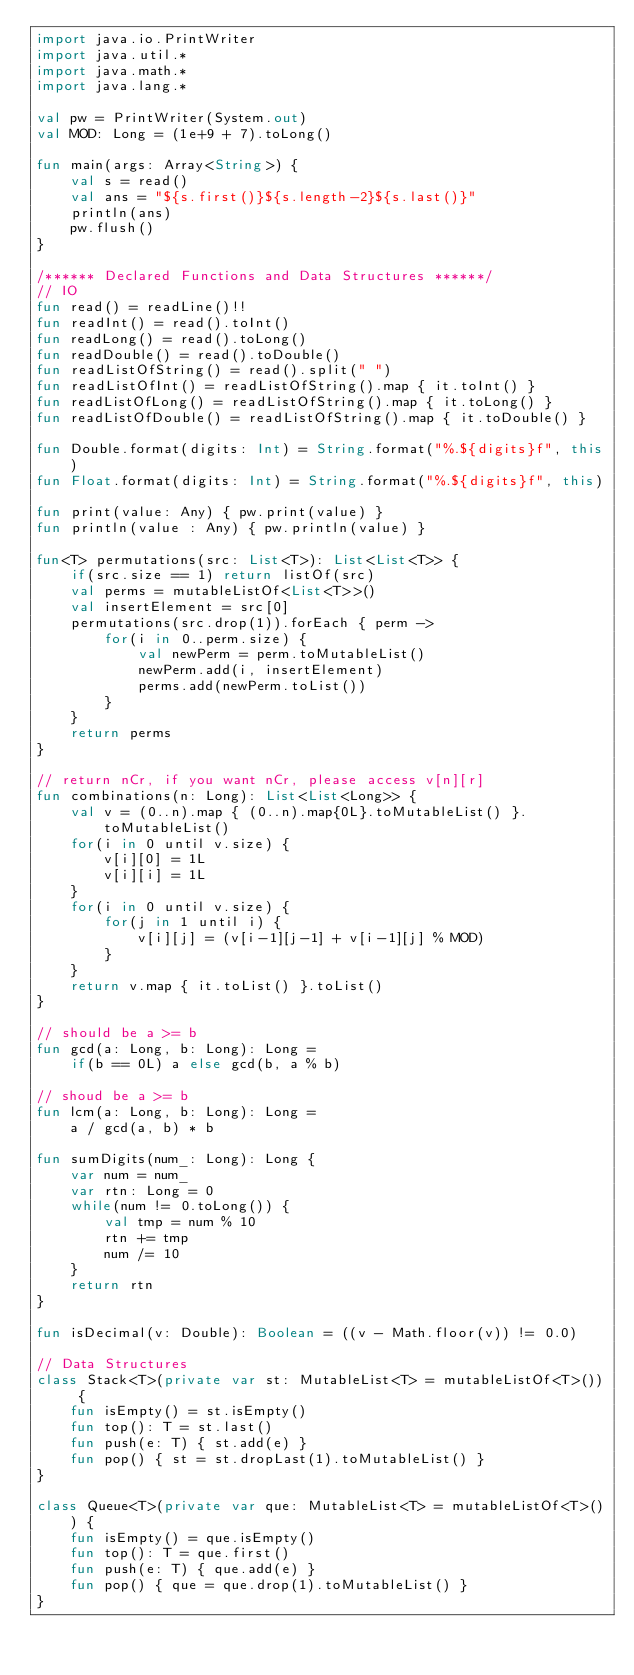<code> <loc_0><loc_0><loc_500><loc_500><_Kotlin_>import java.io.PrintWriter
import java.util.*
import java.math.*
import java.lang.*

val pw = PrintWriter(System.out)
val MOD: Long = (1e+9 + 7).toLong()

fun main(args: Array<String>) {
    val s = read() 
    val ans = "${s.first()}${s.length-2}${s.last()}"
    println(ans)
    pw.flush()
}

/****** Declared Functions and Data Structures ******/
// IO
fun read() = readLine()!!
fun readInt() = read().toInt()
fun readLong() = read().toLong()
fun readDouble() = read().toDouble()
fun readListOfString() = read().split(" ")
fun readListOfInt() = readListOfString().map { it.toInt() }
fun readListOfLong() = readListOfString().map { it.toLong() }
fun readListOfDouble() = readListOfString().map { it.toDouble() }

fun Double.format(digits: Int) = String.format("%.${digits}f", this)
fun Float.format(digits: Int) = String.format("%.${digits}f", this)

fun print(value: Any) { pw.print(value) }
fun println(value : Any) { pw.println(value) }

fun<T> permutations(src: List<T>): List<List<T>> {
    if(src.size == 1) return listOf(src)
    val perms = mutableListOf<List<T>>()
    val insertElement = src[0]
    permutations(src.drop(1)).forEach { perm ->
        for(i in 0..perm.size) {
            val newPerm = perm.toMutableList()
            newPerm.add(i, insertElement)
            perms.add(newPerm.toList())
        }
    }
    return perms
}

// return nCr, if you want nCr, please access v[n][r]
fun combinations(n: Long): List<List<Long>> {
    val v = (0..n).map { (0..n).map{0L}.toMutableList() }.toMutableList()
    for(i in 0 until v.size) {
        v[i][0] = 1L
        v[i][i] = 1L
    }
    for(i in 0 until v.size) {
        for(j in 1 until i) {
            v[i][j] = (v[i-1][j-1] + v[i-1][j] % MOD)
        }
    }
    return v.map { it.toList() }.toList()
}

// should be a >= b
fun gcd(a: Long, b: Long): Long = 
    if(b == 0L) a else gcd(b, a % b)

// shoud be a >= b
fun lcm(a: Long, b: Long): Long = 
    a / gcd(a, b) * b

fun sumDigits(num_: Long): Long {
    var num = num_
    var rtn: Long = 0
    while(num != 0.toLong()) {
        val tmp = num % 10
        rtn += tmp
        num /= 10
    }
    return rtn
}

fun isDecimal(v: Double): Boolean = ((v - Math.floor(v)) != 0.0)

// Data Structures
class Stack<T>(private var st: MutableList<T> = mutableListOf<T>()) {
    fun isEmpty() = st.isEmpty()
    fun top(): T = st.last()
    fun push(e: T) { st.add(e) }
    fun pop() { st = st.dropLast(1).toMutableList() }
}

class Queue<T>(private var que: MutableList<T> = mutableListOf<T>()) {
    fun isEmpty() = que.isEmpty()
    fun top(): T = que.first()
    fun push(e: T) { que.add(e) }
    fun pop() { que = que.drop(1).toMutableList() }
}
</code> 